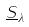<formula> <loc_0><loc_0><loc_500><loc_500>\underline { S } _ { \lambda }</formula> 